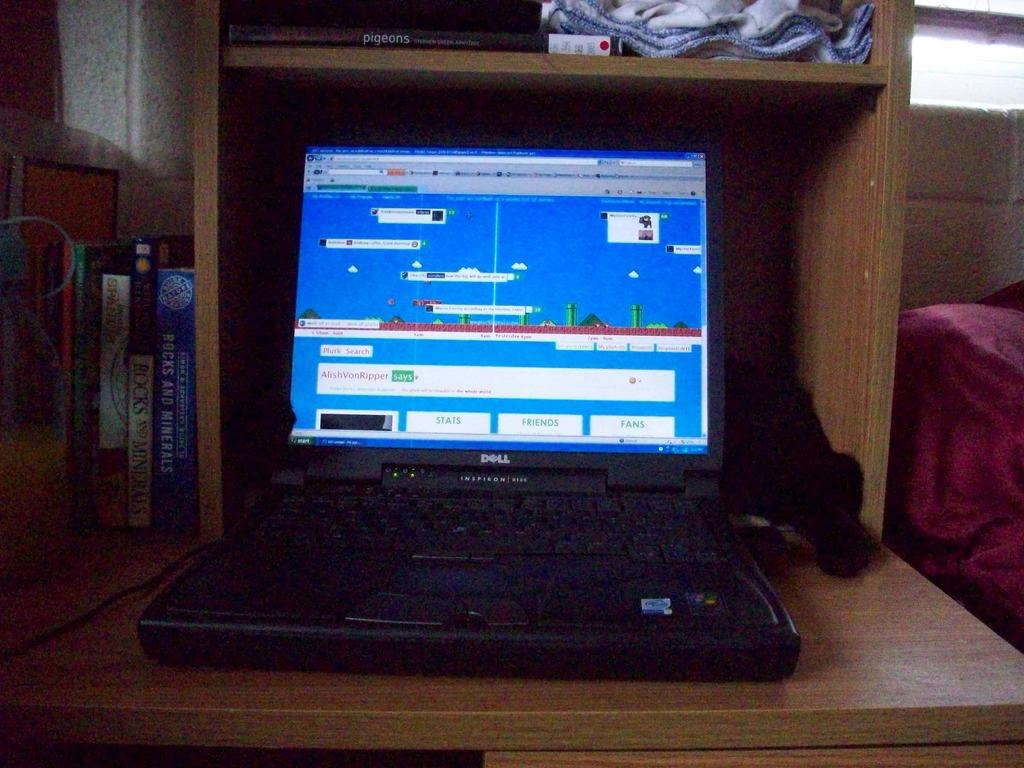<image>
Present a compact description of the photo's key features. a computer window has the word stats at the bottom 